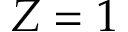<formula> <loc_0><loc_0><loc_500><loc_500>Z = 1</formula> 